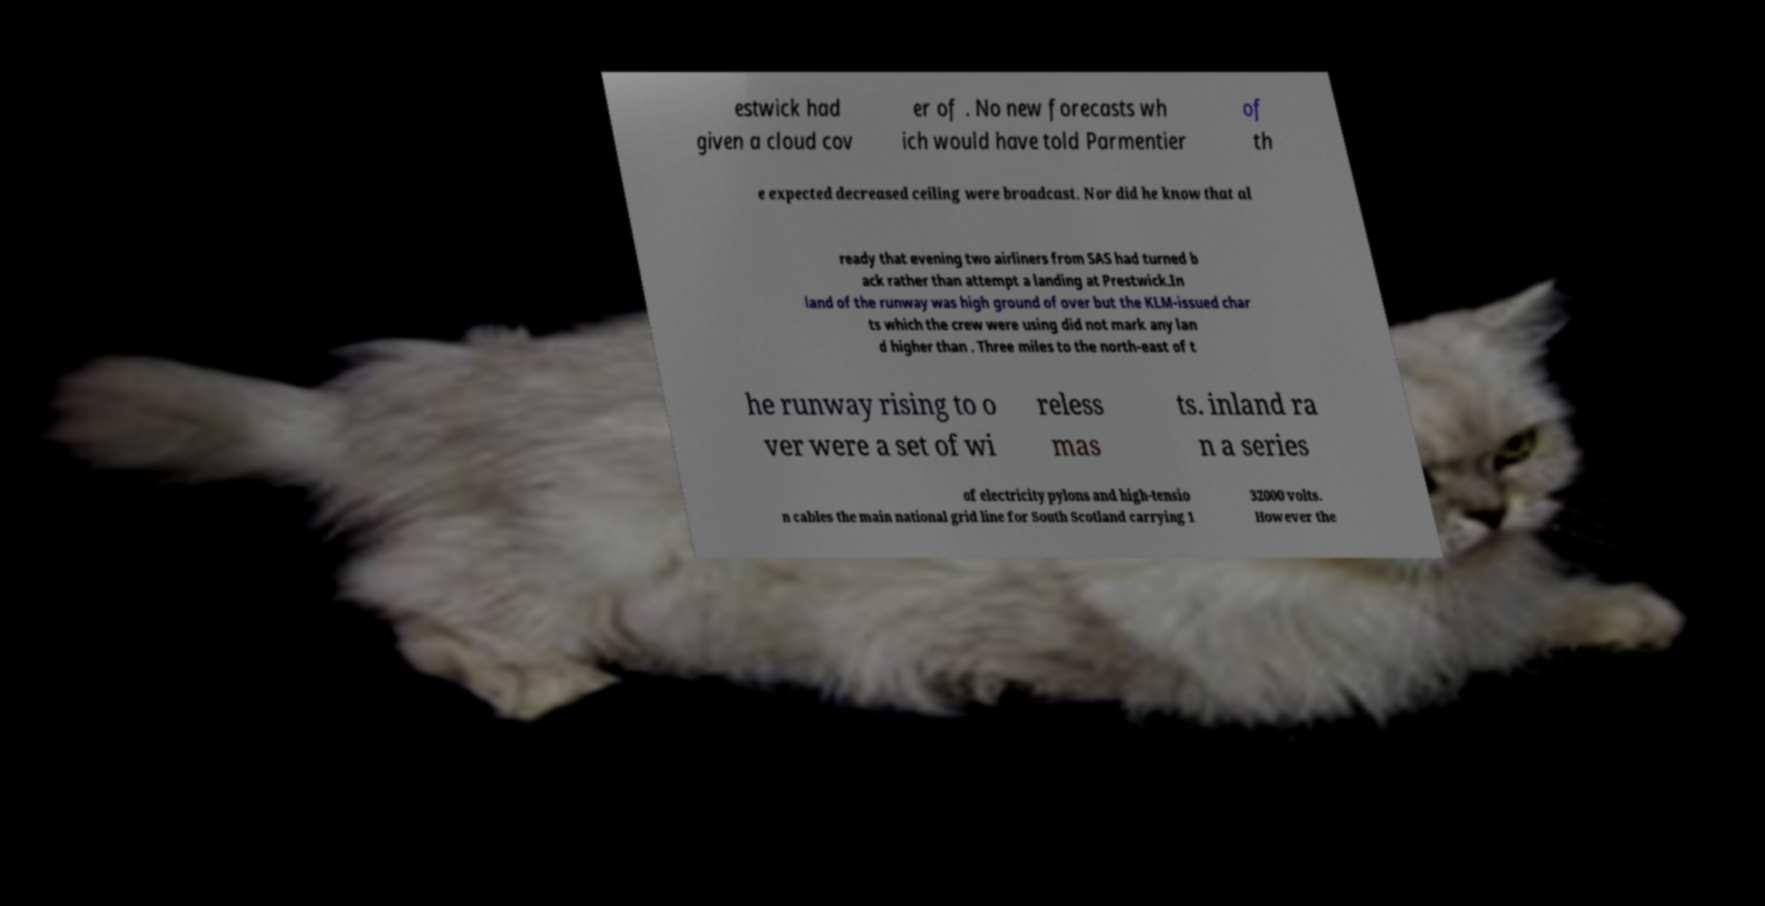For documentation purposes, I need the text within this image transcribed. Could you provide that? estwick had given a cloud cov er of . No new forecasts wh ich would have told Parmentier of th e expected decreased ceiling were broadcast. Nor did he know that al ready that evening two airliners from SAS had turned b ack rather than attempt a landing at Prestwick.In land of the runway was high ground of over but the KLM-issued char ts which the crew were using did not mark any lan d higher than . Three miles to the north-east of t he runway rising to o ver were a set of wi reless mas ts. inland ra n a series of electricity pylons and high-tensio n cables the main national grid line for South Scotland carrying 1 32000 volts. However the 